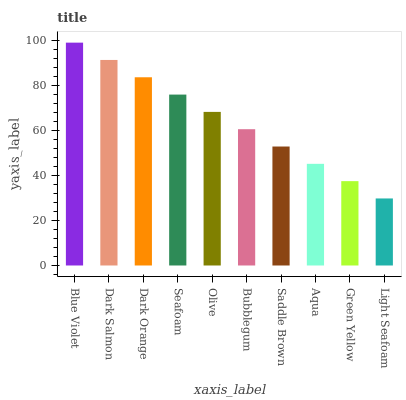Is Light Seafoam the minimum?
Answer yes or no. Yes. Is Blue Violet the maximum?
Answer yes or no. Yes. Is Dark Salmon the minimum?
Answer yes or no. No. Is Dark Salmon the maximum?
Answer yes or no. No. Is Blue Violet greater than Dark Salmon?
Answer yes or no. Yes. Is Dark Salmon less than Blue Violet?
Answer yes or no. Yes. Is Dark Salmon greater than Blue Violet?
Answer yes or no. No. Is Blue Violet less than Dark Salmon?
Answer yes or no. No. Is Olive the high median?
Answer yes or no. Yes. Is Bubblegum the low median?
Answer yes or no. Yes. Is Green Yellow the high median?
Answer yes or no. No. Is Light Seafoam the low median?
Answer yes or no. No. 